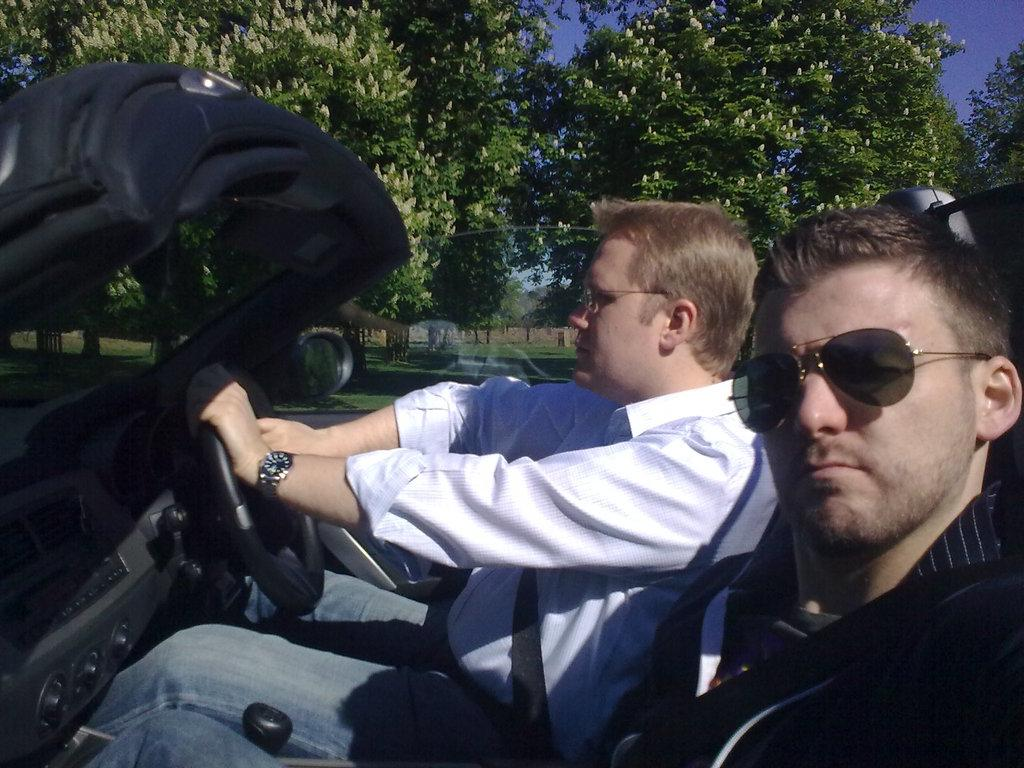How many people are in the image? There are two men in the image. What are the men doing in the image? The men are sitting in a car. What type of vegetation can be seen in the image? There are big trees visible in the image. What is visible in the background of the image? The sky is visible in the image. What type of fiction is the ghost reading in the image? There is no ghost or book present in the image. How does the lift help the men in the image? There is no lift present in the image; the men are sitting in a car. 